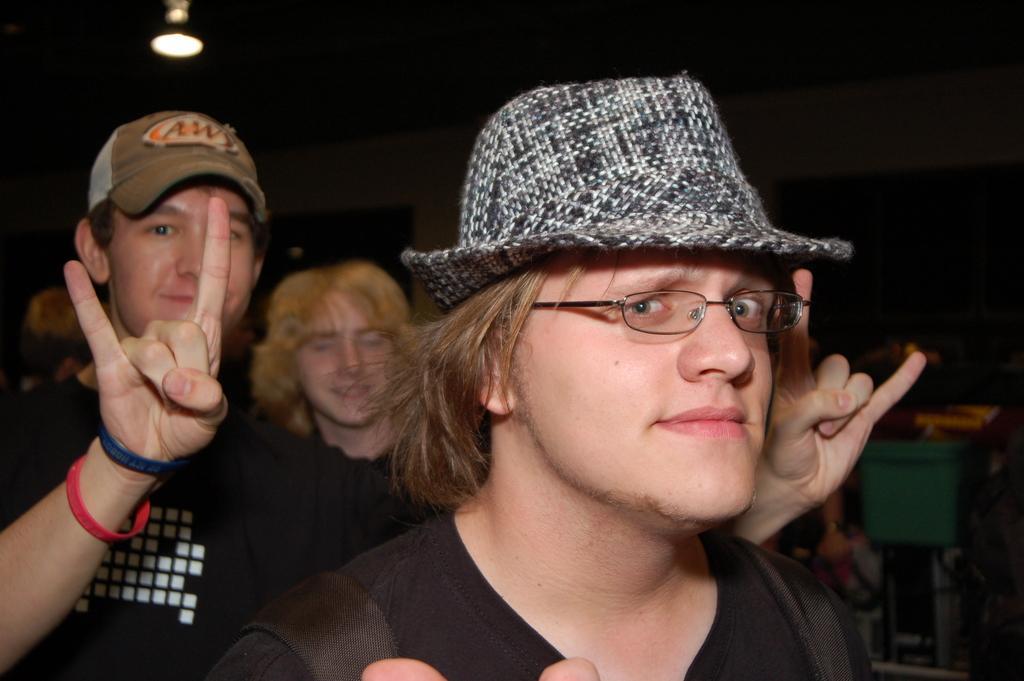Can you describe this image briefly? In this image we can see a man is standing, he is wearing the glasses, he is wearing the black t-shirt, at back there are group of people standing, at above there is the light. 